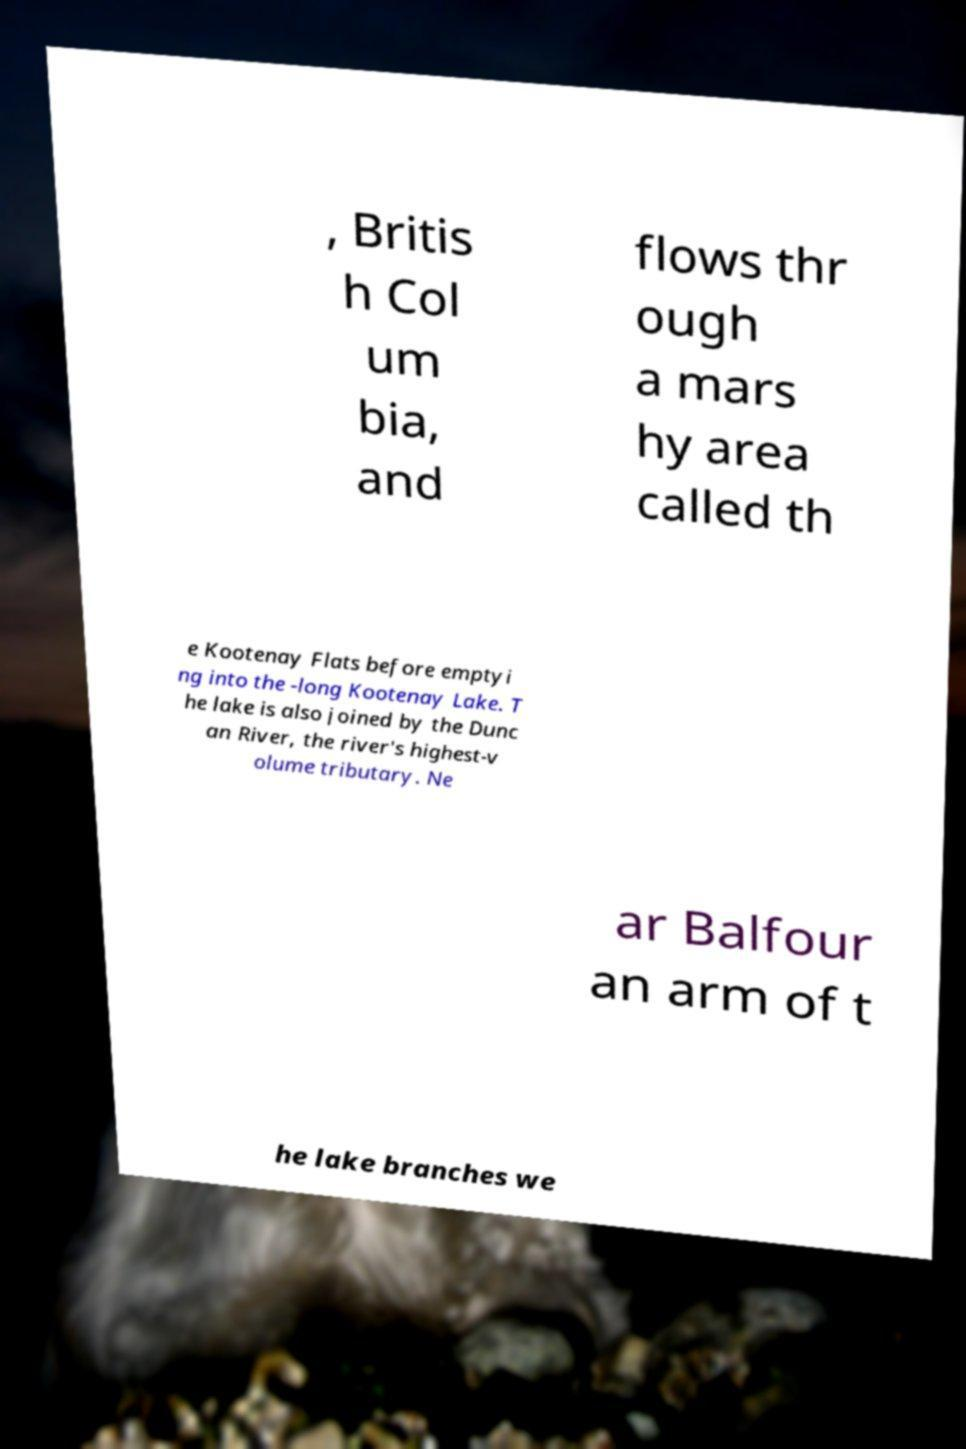Please read and relay the text visible in this image. What does it say? , Britis h Col um bia, and flows thr ough a mars hy area called th e Kootenay Flats before emptyi ng into the -long Kootenay Lake. T he lake is also joined by the Dunc an River, the river's highest-v olume tributary. Ne ar Balfour an arm of t he lake branches we 